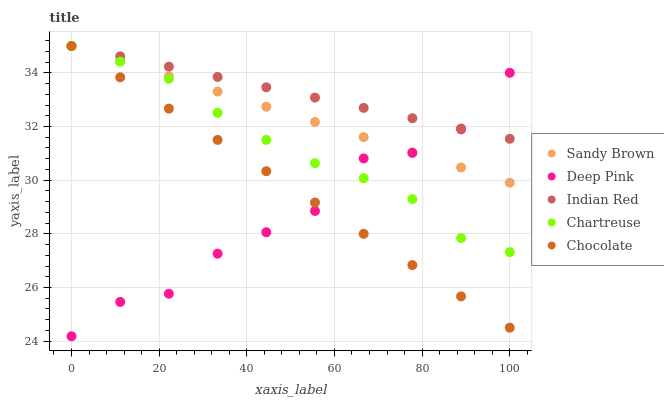Does Deep Pink have the minimum area under the curve?
Answer yes or no. Yes. Does Indian Red have the maximum area under the curve?
Answer yes or no. Yes. Does Sandy Brown have the minimum area under the curve?
Answer yes or no. No. Does Sandy Brown have the maximum area under the curve?
Answer yes or no. No. Is Indian Red the smoothest?
Answer yes or no. Yes. Is Deep Pink the roughest?
Answer yes or no. Yes. Is Sandy Brown the smoothest?
Answer yes or no. No. Is Sandy Brown the roughest?
Answer yes or no. No. Does Deep Pink have the lowest value?
Answer yes or no. Yes. Does Sandy Brown have the lowest value?
Answer yes or no. No. Does Chocolate have the highest value?
Answer yes or no. Yes. Does Deep Pink have the highest value?
Answer yes or no. No. Does Deep Pink intersect Indian Red?
Answer yes or no. Yes. Is Deep Pink less than Indian Red?
Answer yes or no. No. Is Deep Pink greater than Indian Red?
Answer yes or no. No. 